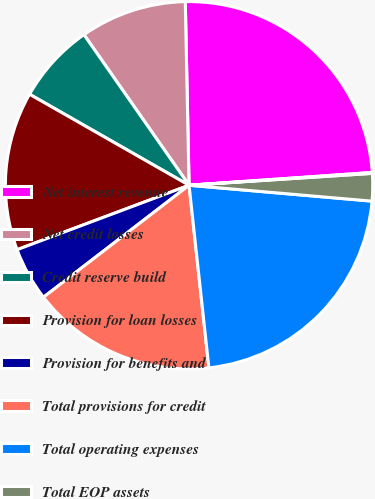<chart> <loc_0><loc_0><loc_500><loc_500><pie_chart><fcel>Net interest revenue<fcel>Net credit losses<fcel>Credit reserve build<fcel>Provision for loan losses<fcel>Provision for benefits and<fcel>Total provisions for credit<fcel>Total operating expenses<fcel>Total EOP assets<fcel>Total EOP deposits<nl><fcel>24.22%<fcel>9.37%<fcel>7.05%<fcel>13.96%<fcel>4.73%<fcel>16.29%<fcel>21.9%<fcel>2.41%<fcel>0.08%<nl></chart> 